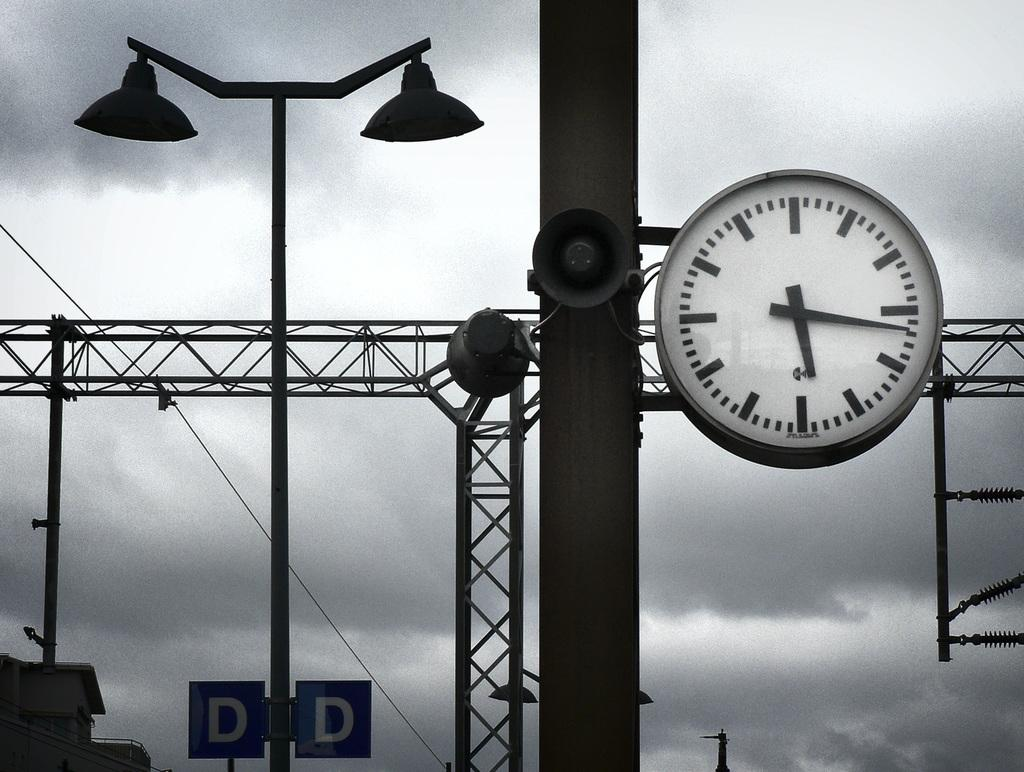<image>
Summarize the visual content of the image. Structures with a large clock and lights as well as two signs with the letter D. 